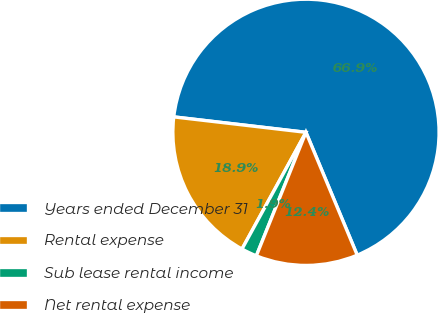Convert chart to OTSL. <chart><loc_0><loc_0><loc_500><loc_500><pie_chart><fcel>Years ended December 31<fcel>Rental expense<fcel>Sub lease rental income<fcel>Net rental expense<nl><fcel>66.86%<fcel>18.87%<fcel>1.9%<fcel>12.37%<nl></chart> 